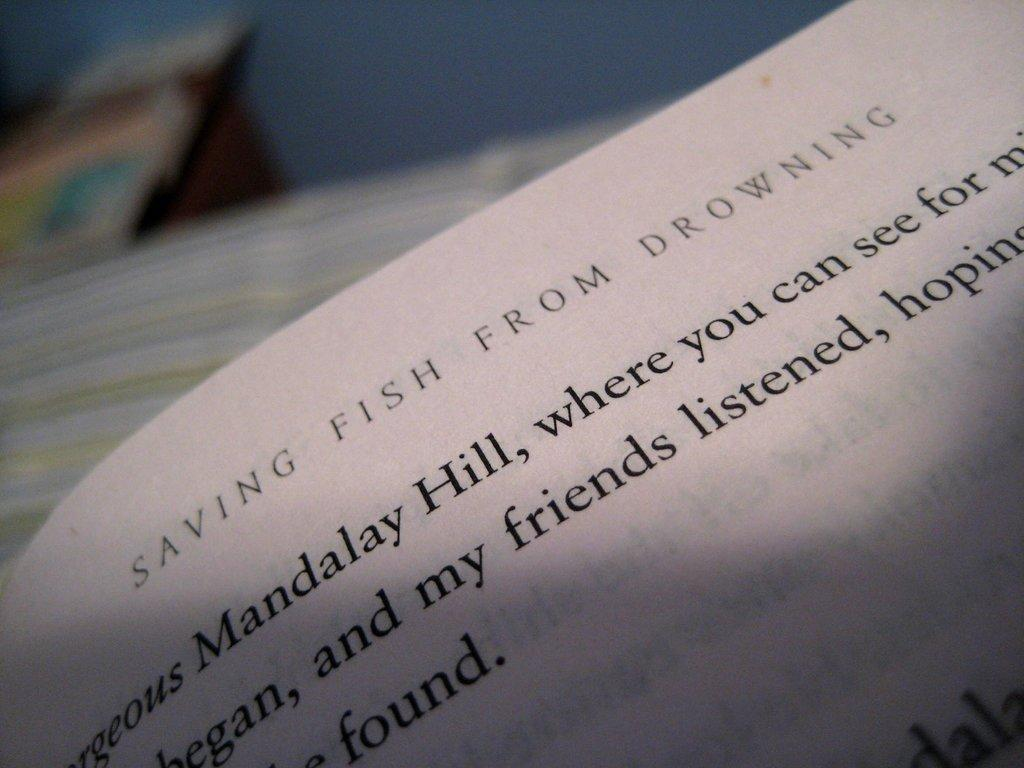<image>
Describe the image concisely. the top of a page from the book saving fish from drowning 